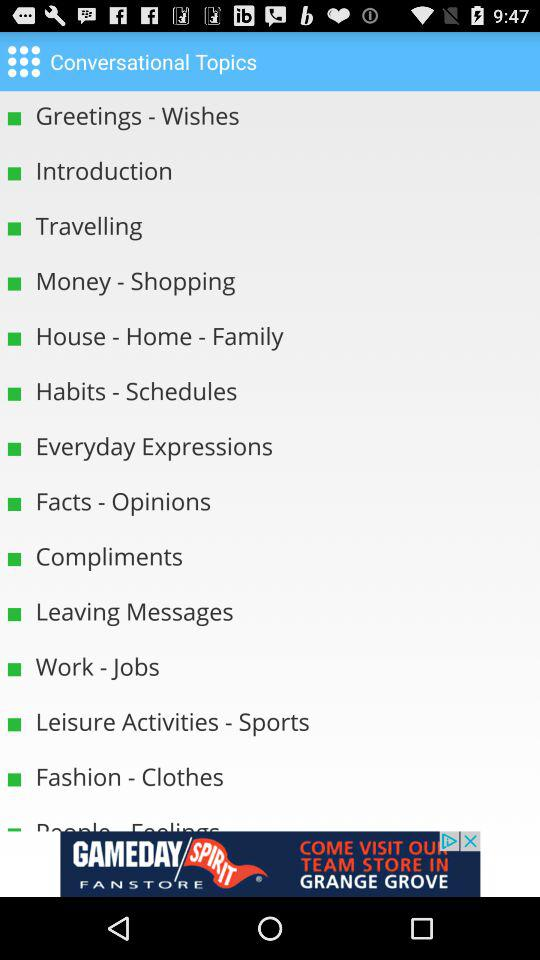Which topics come under money?
When the provided information is insufficient, respond with <no answer>. <no answer> 